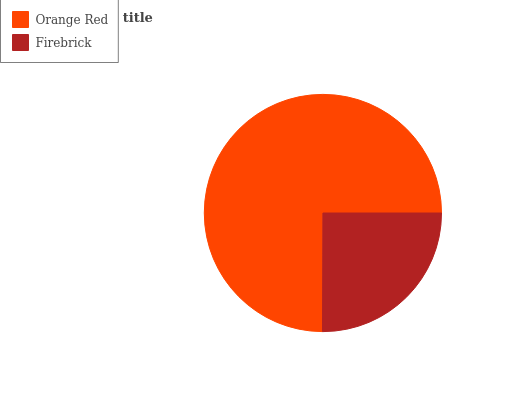Is Firebrick the minimum?
Answer yes or no. Yes. Is Orange Red the maximum?
Answer yes or no. Yes. Is Firebrick the maximum?
Answer yes or no. No. Is Orange Red greater than Firebrick?
Answer yes or no. Yes. Is Firebrick less than Orange Red?
Answer yes or no. Yes. Is Firebrick greater than Orange Red?
Answer yes or no. No. Is Orange Red less than Firebrick?
Answer yes or no. No. Is Orange Red the high median?
Answer yes or no. Yes. Is Firebrick the low median?
Answer yes or no. Yes. Is Firebrick the high median?
Answer yes or no. No. Is Orange Red the low median?
Answer yes or no. No. 